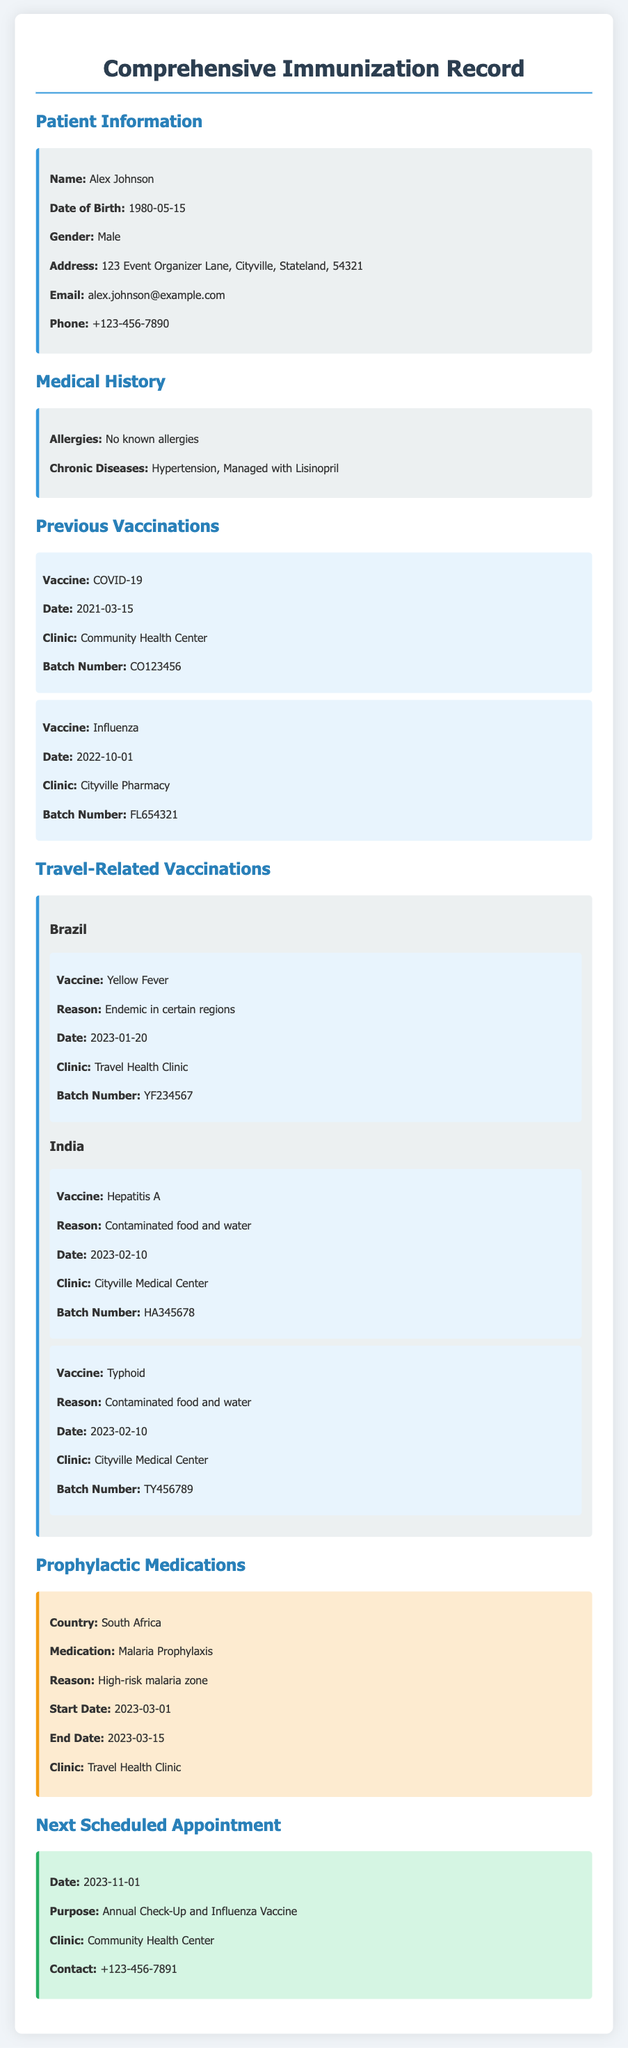What is the patient's name? The patient's name is specified under "Patient Information" in the document.
Answer: Alex Johnson What is the date of birth? The date of birth can be found in the "Patient Information" section.
Answer: 1980-05-15 Which clinic administered the Yellow Fever vaccine? The clinic name is stated in the "Travel-Related Vaccinations" section for Brazil.
Answer: Travel Health Clinic What medication is taken for hypertension? The medication for hypertension is mentioned in the "Medical History" section.
Answer: Lisinopril When is the next scheduled appointment? The date for the next appointment is provided in the "Next Scheduled Appointment" section.
Answer: 2023-11-01 What is the reason for the Hepatitis A vaccination? The reason for the vaccination is specified in the "Travel-Related Vaccinations" section for India.
Answer: Contaminated food and water How long was the malaria prophylaxis taken? The duration is calculated based on the start and end dates provided in the "Prophylactic Medications" section.
Answer: 15 days What is the batch number of the Influenza vaccine? The batch number is mentioned alongside the Influenza vaccination in the "Previous Vaccinations" section.
Answer: FL654321 How many travel-related vaccinations were given for India? The number can be determined from the "Travel-Related Vaccinations" section for India.
Answer: 2 